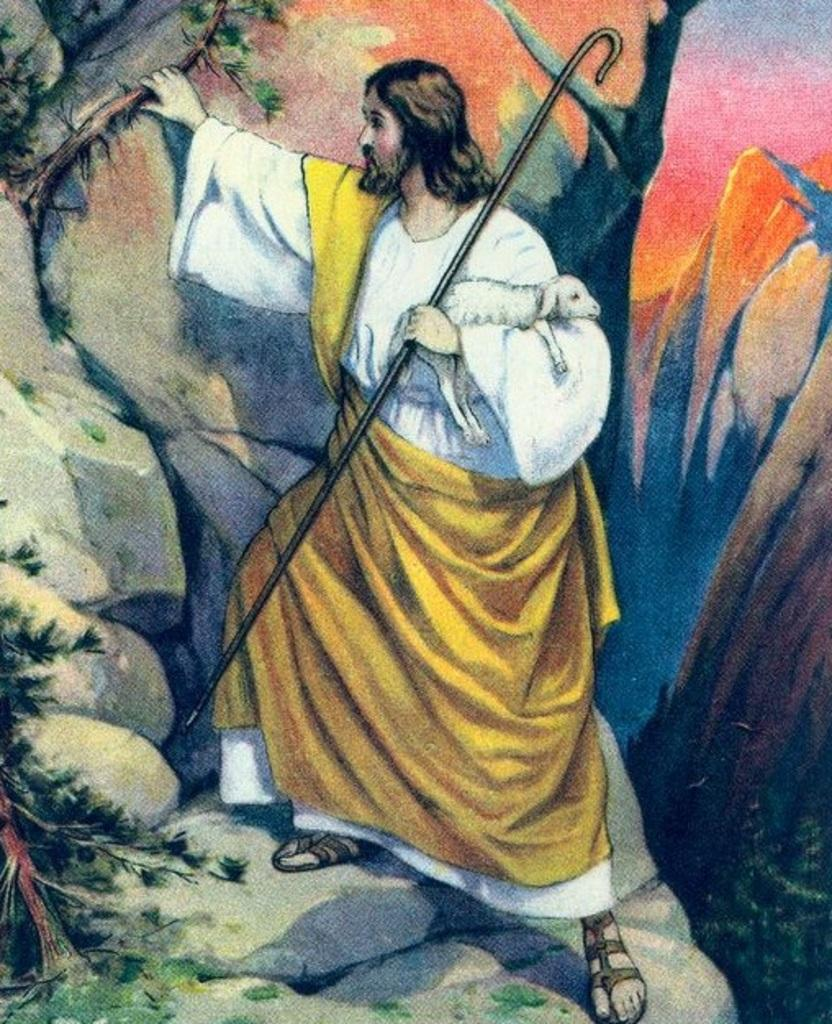What is the main subject of the painting? The painting depicts a person standing. What type of footwear is the person wearing? The person is wearing sandals. What object is the person holding in their hand? The person is holding an animal in their hand. What natural elements can be seen in the painting? There are leaves, stones, mountains, and the sky visible in the painting. What language is the person speaking in the painting? The painting is a visual representation and does not depict any spoken language. Can you tell me how many rabbits are present in the painting? There are no rabbits present in the painting; the person is holding an animal, but it is not a rabbit. 